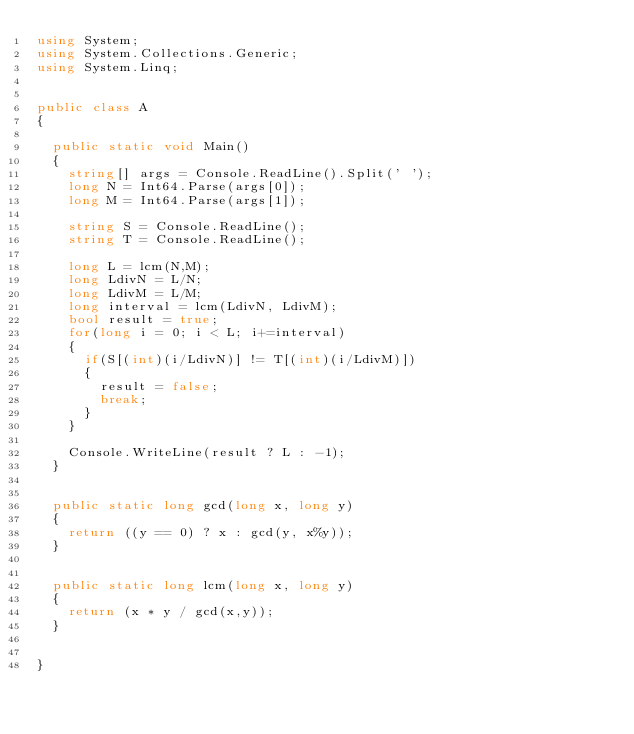<code> <loc_0><loc_0><loc_500><loc_500><_C#_>using System;
using System.Collections.Generic;
using System.Linq;


public class A
{
	
	public static void Main()
	{
		string[] args = Console.ReadLine().Split(' ');
		long N = Int64.Parse(args[0]);
		long M = Int64.Parse(args[1]);
		
		string S = Console.ReadLine();
		string T = Console.ReadLine();

		long L = lcm(N,M);
		long LdivN = L/N;
		long LdivM = L/M;
		long interval = lcm(LdivN, LdivM);		
		bool result = true;
		for(long i = 0; i < L; i+=interval)
		{
			if(S[(int)(i/LdivN)] != T[(int)(i/LdivM)])
			{
				result = false;
				break;
			}
		}
		
		Console.WriteLine(result ? L : -1);
	}
	
	
	public static long gcd(long x, long y)
	{
		return ((y == 0) ? x : gcd(y, x%y));
	}
	
	
	public static long lcm(long x, long y)
	{
		return (x * y / gcd(x,y));
	}
	
	
}



</code> 